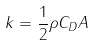Convert formula to latex. <formula><loc_0><loc_0><loc_500><loc_500>k = \frac { 1 } { 2 } \rho C _ { D } A</formula> 